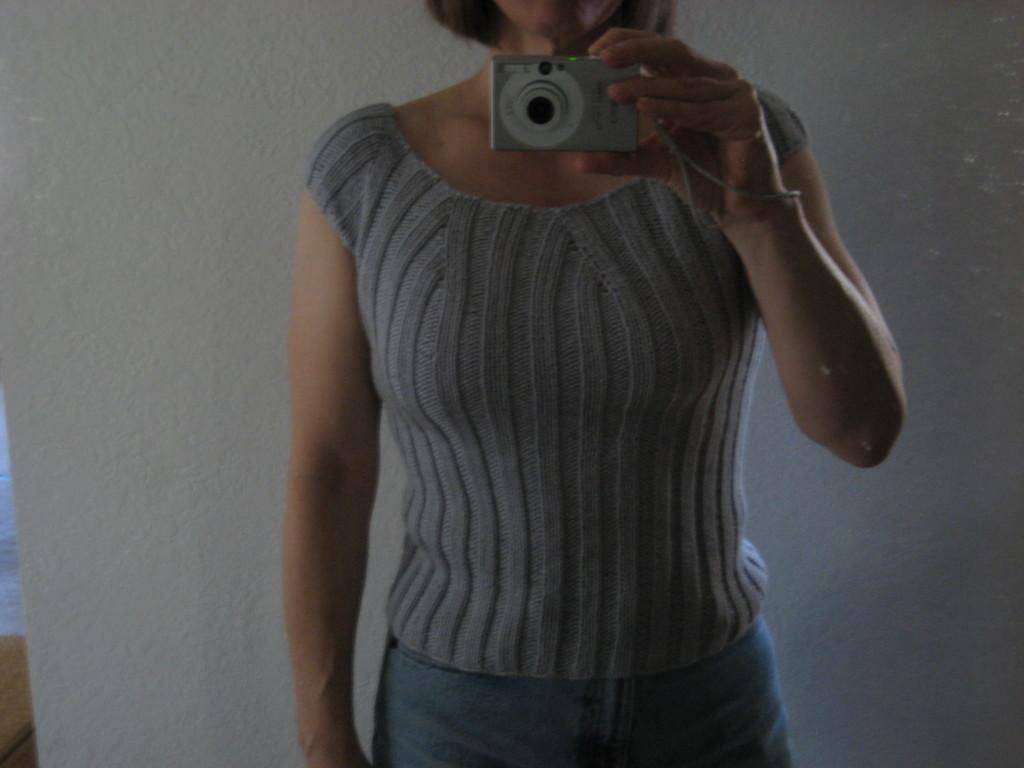Who is the main subject in the image? There is a woman in the image. What is the woman doing in the image? The woman is standing in the image. What object is the woman holding in her hand? The woman is holding a camera in her hand. What type of net can be seen in the image? There is no net present in the image; it features a woman standing and holding a camera. 